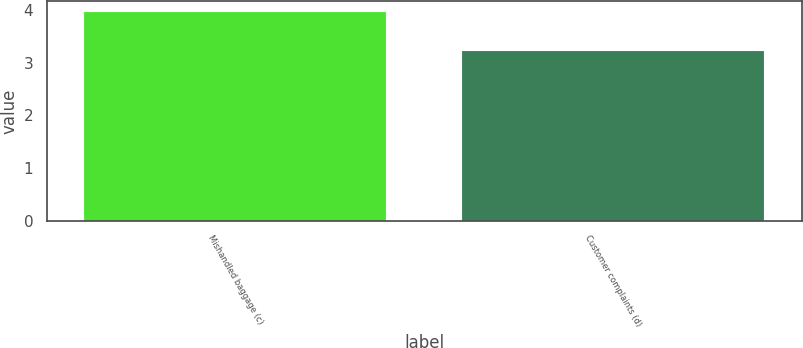Convert chart. <chart><loc_0><loc_0><loc_500><loc_500><bar_chart><fcel>Mishandled baggage (c)<fcel>Customer complaints (d)<nl><fcel>3.97<fcel>3.22<nl></chart> 